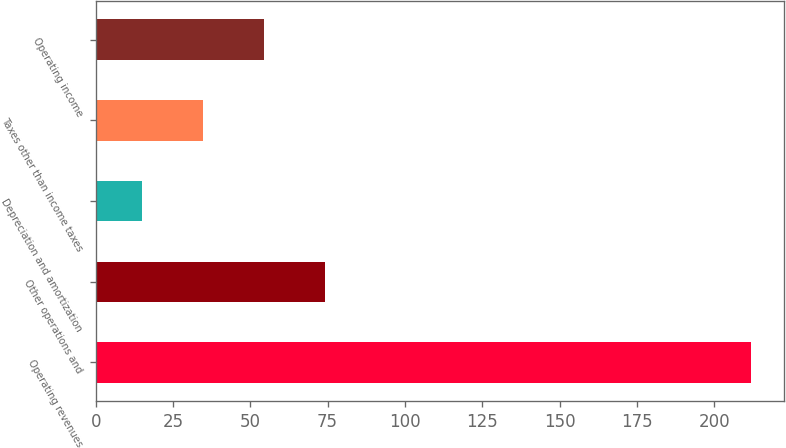Convert chart. <chart><loc_0><loc_0><loc_500><loc_500><bar_chart><fcel>Operating revenues<fcel>Other operations and<fcel>Depreciation and amortization<fcel>Taxes other than income taxes<fcel>Operating income<nl><fcel>212<fcel>74.1<fcel>15<fcel>34.7<fcel>54.4<nl></chart> 